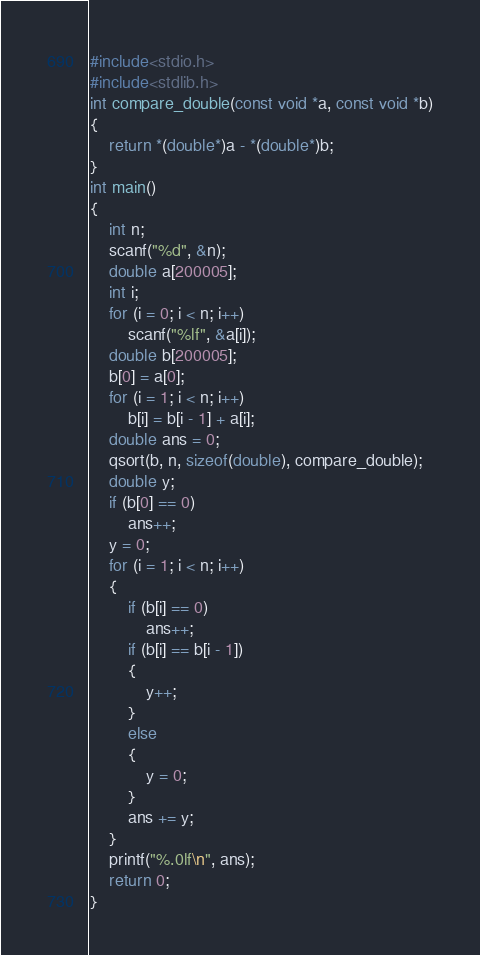<code> <loc_0><loc_0><loc_500><loc_500><_C_>#include<stdio.h>
#include<stdlib.h>
int compare_double(const void *a, const void *b)
{
    return *(double*)a - *(double*)b;
}
int main()
{
    int n;
    scanf("%d", &n);
    double a[200005];
    int i;
    for (i = 0; i < n; i++)
        scanf("%lf", &a[i]);
    double b[200005];
    b[0] = a[0];
    for (i = 1; i < n; i++)
        b[i] = b[i - 1] + a[i];
    double ans = 0;
    qsort(b, n, sizeof(double), compare_double);
    double y;
    if (b[0] == 0)
        ans++;
    y = 0;
    for (i = 1; i < n; i++)
    {
        if (b[i] == 0)
            ans++;
        if (b[i] == b[i - 1])
        {
            y++;
        }
        else
        {
            y = 0;
        }
        ans += y;
    }
    printf("%.0lf\n", ans);
    return 0;
}</code> 